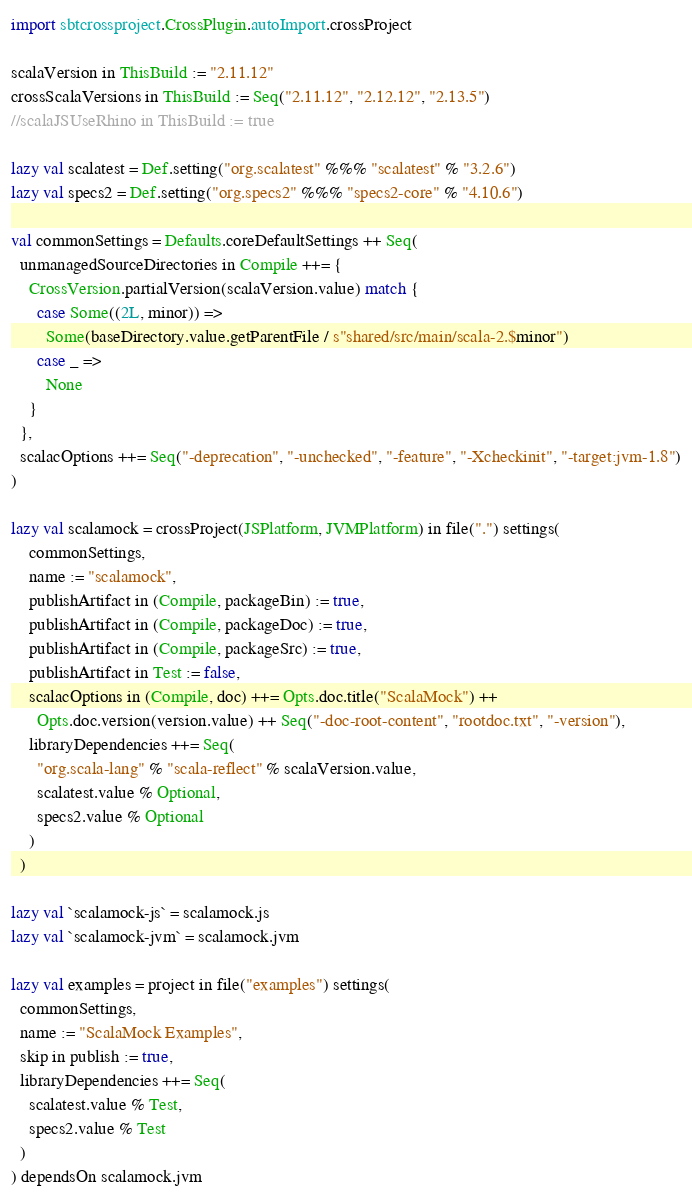Convert code to text. <code><loc_0><loc_0><loc_500><loc_500><_Scala_>import sbtcrossproject.CrossPlugin.autoImport.crossProject

scalaVersion in ThisBuild := "2.11.12"
crossScalaVersions in ThisBuild := Seq("2.11.12", "2.12.12", "2.13.5")
//scalaJSUseRhino in ThisBuild := true

lazy val scalatest = Def.setting("org.scalatest" %%% "scalatest" % "3.2.6")
lazy val specs2 = Def.setting("org.specs2" %%% "specs2-core" % "4.10.6")

val commonSettings = Defaults.coreDefaultSettings ++ Seq(
  unmanagedSourceDirectories in Compile ++= {
    CrossVersion.partialVersion(scalaVersion.value) match {
      case Some((2L, minor)) =>
        Some(baseDirectory.value.getParentFile / s"shared/src/main/scala-2.$minor")
      case _ =>
        None
    }
  },
  scalacOptions ++= Seq("-deprecation", "-unchecked", "-feature", "-Xcheckinit", "-target:jvm-1.8")
)

lazy val scalamock = crossProject(JSPlatform, JVMPlatform) in file(".") settings(
    commonSettings,
    name := "scalamock",
    publishArtifact in (Compile, packageBin) := true,
    publishArtifact in (Compile, packageDoc) := true,
    publishArtifact in (Compile, packageSrc) := true,
    publishArtifact in Test := false,
    scalacOptions in (Compile, doc) ++= Opts.doc.title("ScalaMock") ++
      Opts.doc.version(version.value) ++ Seq("-doc-root-content", "rootdoc.txt", "-version"),
    libraryDependencies ++= Seq(
      "org.scala-lang" % "scala-reflect" % scalaVersion.value,
      scalatest.value % Optional,
      specs2.value % Optional
    )
  )

lazy val `scalamock-js` = scalamock.js
lazy val `scalamock-jvm` = scalamock.jvm

lazy val examples = project in file("examples") settings(
  commonSettings,
  name := "ScalaMock Examples",
  skip in publish := true,
  libraryDependencies ++= Seq(
    scalatest.value % Test,
    specs2.value % Test
  )
) dependsOn scalamock.jvm
</code> 